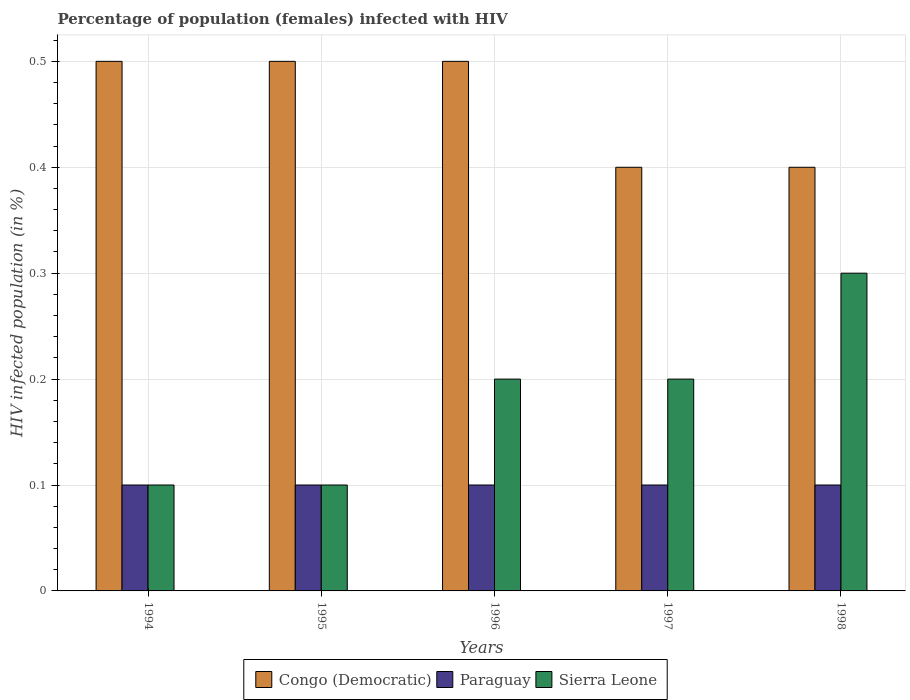How many different coloured bars are there?
Ensure brevity in your answer.  3. Are the number of bars on each tick of the X-axis equal?
Make the answer very short. Yes. In which year was the percentage of HIV infected female population in Paraguay minimum?
Your answer should be very brief. 1994. What is the total percentage of HIV infected female population in Paraguay in the graph?
Keep it short and to the point. 0.5. What is the difference between the percentage of HIV infected female population in Congo (Democratic) in 1996 and the percentage of HIV infected female population in Paraguay in 1995?
Provide a short and direct response. 0.4. What is the average percentage of HIV infected female population in Paraguay per year?
Offer a terse response. 0.1. What is the ratio of the percentage of HIV infected female population in Sierra Leone in 1994 to that in 1998?
Offer a terse response. 0.33. What is the difference between the highest and the lowest percentage of HIV infected female population in Congo (Democratic)?
Provide a succinct answer. 0.1. In how many years, is the percentage of HIV infected female population in Sierra Leone greater than the average percentage of HIV infected female population in Sierra Leone taken over all years?
Provide a short and direct response. 3. Is the sum of the percentage of HIV infected female population in Congo (Democratic) in 1997 and 1998 greater than the maximum percentage of HIV infected female population in Sierra Leone across all years?
Your response must be concise. Yes. What does the 1st bar from the left in 1997 represents?
Keep it short and to the point. Congo (Democratic). What does the 1st bar from the right in 1997 represents?
Offer a very short reply. Sierra Leone. Is it the case that in every year, the sum of the percentage of HIV infected female population in Paraguay and percentage of HIV infected female population in Congo (Democratic) is greater than the percentage of HIV infected female population in Sierra Leone?
Ensure brevity in your answer.  Yes. What is the difference between two consecutive major ticks on the Y-axis?
Provide a succinct answer. 0.1. Where does the legend appear in the graph?
Your answer should be compact. Bottom center. How many legend labels are there?
Your answer should be compact. 3. How are the legend labels stacked?
Ensure brevity in your answer.  Horizontal. What is the title of the graph?
Offer a terse response. Percentage of population (females) infected with HIV. Does "Indonesia" appear as one of the legend labels in the graph?
Provide a short and direct response. No. What is the label or title of the Y-axis?
Provide a succinct answer. HIV infected population (in %). What is the HIV infected population (in %) of Congo (Democratic) in 1994?
Offer a terse response. 0.5. What is the HIV infected population (in %) in Paraguay in 1994?
Offer a very short reply. 0.1. What is the HIV infected population (in %) of Sierra Leone in 1994?
Your response must be concise. 0.1. What is the HIV infected population (in %) of Congo (Democratic) in 1995?
Your answer should be very brief. 0.5. What is the HIV infected population (in %) of Paraguay in 1995?
Your answer should be compact. 0.1. What is the HIV infected population (in %) of Sierra Leone in 1997?
Keep it short and to the point. 0.2. What is the HIV infected population (in %) of Congo (Democratic) in 1998?
Provide a short and direct response. 0.4. What is the HIV infected population (in %) of Sierra Leone in 1998?
Provide a short and direct response. 0.3. Across all years, what is the maximum HIV infected population (in %) in Paraguay?
Offer a terse response. 0.1. Across all years, what is the minimum HIV infected population (in %) in Paraguay?
Keep it short and to the point. 0.1. Across all years, what is the minimum HIV infected population (in %) in Sierra Leone?
Make the answer very short. 0.1. What is the total HIV infected population (in %) of Sierra Leone in the graph?
Your answer should be compact. 0.9. What is the difference between the HIV infected population (in %) in Congo (Democratic) in 1994 and that in 1995?
Your response must be concise. 0. What is the difference between the HIV infected population (in %) in Sierra Leone in 1994 and that in 1995?
Provide a short and direct response. 0. What is the difference between the HIV infected population (in %) of Congo (Democratic) in 1994 and that in 1996?
Provide a succinct answer. 0. What is the difference between the HIV infected population (in %) in Paraguay in 1994 and that in 1996?
Keep it short and to the point. 0. What is the difference between the HIV infected population (in %) of Sierra Leone in 1994 and that in 1996?
Make the answer very short. -0.1. What is the difference between the HIV infected population (in %) of Paraguay in 1994 and that in 1997?
Offer a terse response. 0. What is the difference between the HIV infected population (in %) of Sierra Leone in 1994 and that in 1998?
Your answer should be very brief. -0.2. What is the difference between the HIV infected population (in %) in Congo (Democratic) in 1995 and that in 1997?
Give a very brief answer. 0.1. What is the difference between the HIV infected population (in %) in Sierra Leone in 1995 and that in 1997?
Your answer should be very brief. -0.1. What is the difference between the HIV infected population (in %) in Congo (Democratic) in 1995 and that in 1998?
Provide a short and direct response. 0.1. What is the difference between the HIV infected population (in %) in Paraguay in 1995 and that in 1998?
Your answer should be compact. 0. What is the difference between the HIV infected population (in %) in Congo (Democratic) in 1996 and that in 1997?
Your response must be concise. 0.1. What is the difference between the HIV infected population (in %) of Paraguay in 1996 and that in 1997?
Keep it short and to the point. 0. What is the difference between the HIV infected population (in %) of Paraguay in 1996 and that in 1998?
Offer a very short reply. 0. What is the difference between the HIV infected population (in %) of Congo (Democratic) in 1997 and that in 1998?
Give a very brief answer. 0. What is the difference between the HIV infected population (in %) in Paraguay in 1994 and the HIV infected population (in %) in Sierra Leone in 1995?
Your answer should be compact. 0. What is the difference between the HIV infected population (in %) of Paraguay in 1994 and the HIV infected population (in %) of Sierra Leone in 1996?
Offer a terse response. -0.1. What is the difference between the HIV infected population (in %) in Congo (Democratic) in 1994 and the HIV infected population (in %) in Paraguay in 1997?
Your answer should be very brief. 0.4. What is the difference between the HIV infected population (in %) of Congo (Democratic) in 1994 and the HIV infected population (in %) of Sierra Leone in 1997?
Offer a terse response. 0.3. What is the difference between the HIV infected population (in %) of Congo (Democratic) in 1994 and the HIV infected population (in %) of Paraguay in 1998?
Your answer should be compact. 0.4. What is the difference between the HIV infected population (in %) of Congo (Democratic) in 1994 and the HIV infected population (in %) of Sierra Leone in 1998?
Your response must be concise. 0.2. What is the difference between the HIV infected population (in %) in Paraguay in 1994 and the HIV infected population (in %) in Sierra Leone in 1998?
Provide a short and direct response. -0.2. What is the difference between the HIV infected population (in %) in Congo (Democratic) in 1995 and the HIV infected population (in %) in Sierra Leone in 1996?
Offer a terse response. 0.3. What is the difference between the HIV infected population (in %) of Congo (Democratic) in 1995 and the HIV infected population (in %) of Sierra Leone in 1997?
Give a very brief answer. 0.3. What is the difference between the HIV infected population (in %) of Paraguay in 1995 and the HIV infected population (in %) of Sierra Leone in 1997?
Your response must be concise. -0.1. What is the difference between the HIV infected population (in %) in Congo (Democratic) in 1995 and the HIV infected population (in %) in Sierra Leone in 1998?
Ensure brevity in your answer.  0.2. What is the difference between the HIV infected population (in %) in Paraguay in 1995 and the HIV infected population (in %) in Sierra Leone in 1998?
Offer a terse response. -0.2. What is the difference between the HIV infected population (in %) in Paraguay in 1996 and the HIV infected population (in %) in Sierra Leone in 1997?
Ensure brevity in your answer.  -0.1. What is the difference between the HIV infected population (in %) in Congo (Democratic) in 1996 and the HIV infected population (in %) in Paraguay in 1998?
Your answer should be very brief. 0.4. What is the difference between the HIV infected population (in %) in Paraguay in 1996 and the HIV infected population (in %) in Sierra Leone in 1998?
Your response must be concise. -0.2. What is the difference between the HIV infected population (in %) in Congo (Democratic) in 1997 and the HIV infected population (in %) in Paraguay in 1998?
Keep it short and to the point. 0.3. What is the average HIV infected population (in %) in Congo (Democratic) per year?
Offer a terse response. 0.46. What is the average HIV infected population (in %) in Sierra Leone per year?
Offer a very short reply. 0.18. In the year 1994, what is the difference between the HIV infected population (in %) of Congo (Democratic) and HIV infected population (in %) of Paraguay?
Offer a terse response. 0.4. In the year 1994, what is the difference between the HIV infected population (in %) of Paraguay and HIV infected population (in %) of Sierra Leone?
Your response must be concise. 0. In the year 1997, what is the difference between the HIV infected population (in %) of Congo (Democratic) and HIV infected population (in %) of Paraguay?
Offer a very short reply. 0.3. In the year 1997, what is the difference between the HIV infected population (in %) in Congo (Democratic) and HIV infected population (in %) in Sierra Leone?
Provide a succinct answer. 0.2. In the year 1997, what is the difference between the HIV infected population (in %) of Paraguay and HIV infected population (in %) of Sierra Leone?
Ensure brevity in your answer.  -0.1. In the year 1998, what is the difference between the HIV infected population (in %) in Congo (Democratic) and HIV infected population (in %) in Paraguay?
Your answer should be very brief. 0.3. In the year 1998, what is the difference between the HIV infected population (in %) of Paraguay and HIV infected population (in %) of Sierra Leone?
Your response must be concise. -0.2. What is the ratio of the HIV infected population (in %) of Congo (Democratic) in 1994 to that in 1995?
Provide a succinct answer. 1. What is the ratio of the HIV infected population (in %) in Sierra Leone in 1994 to that in 1995?
Your answer should be very brief. 1. What is the ratio of the HIV infected population (in %) of Paraguay in 1994 to that in 1996?
Your answer should be very brief. 1. What is the ratio of the HIV infected population (in %) of Congo (Democratic) in 1994 to that in 1997?
Ensure brevity in your answer.  1.25. What is the ratio of the HIV infected population (in %) of Paraguay in 1994 to that in 1997?
Make the answer very short. 1. What is the ratio of the HIV infected population (in %) in Sierra Leone in 1994 to that in 1997?
Give a very brief answer. 0.5. What is the ratio of the HIV infected population (in %) of Sierra Leone in 1994 to that in 1998?
Make the answer very short. 0.33. What is the ratio of the HIV infected population (in %) of Congo (Democratic) in 1995 to that in 1997?
Your answer should be very brief. 1.25. What is the ratio of the HIV infected population (in %) of Paraguay in 1995 to that in 1997?
Offer a terse response. 1. What is the ratio of the HIV infected population (in %) of Congo (Democratic) in 1995 to that in 1998?
Provide a succinct answer. 1.25. What is the ratio of the HIV infected population (in %) of Paraguay in 1995 to that in 1998?
Make the answer very short. 1. What is the ratio of the HIV infected population (in %) of Sierra Leone in 1995 to that in 1998?
Offer a terse response. 0.33. What is the ratio of the HIV infected population (in %) in Congo (Democratic) in 1996 to that in 1998?
Provide a succinct answer. 1.25. What is the ratio of the HIV infected population (in %) in Paraguay in 1997 to that in 1998?
Provide a succinct answer. 1. What is the difference between the highest and the lowest HIV infected population (in %) in Sierra Leone?
Provide a short and direct response. 0.2. 